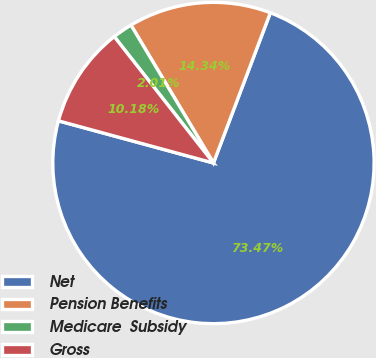<chart> <loc_0><loc_0><loc_500><loc_500><pie_chart><fcel>Net<fcel>Pension Benefits<fcel>Medicare  Subsidy<fcel>Gross<nl><fcel>73.46%<fcel>14.34%<fcel>2.01%<fcel>10.18%<nl></chart> 